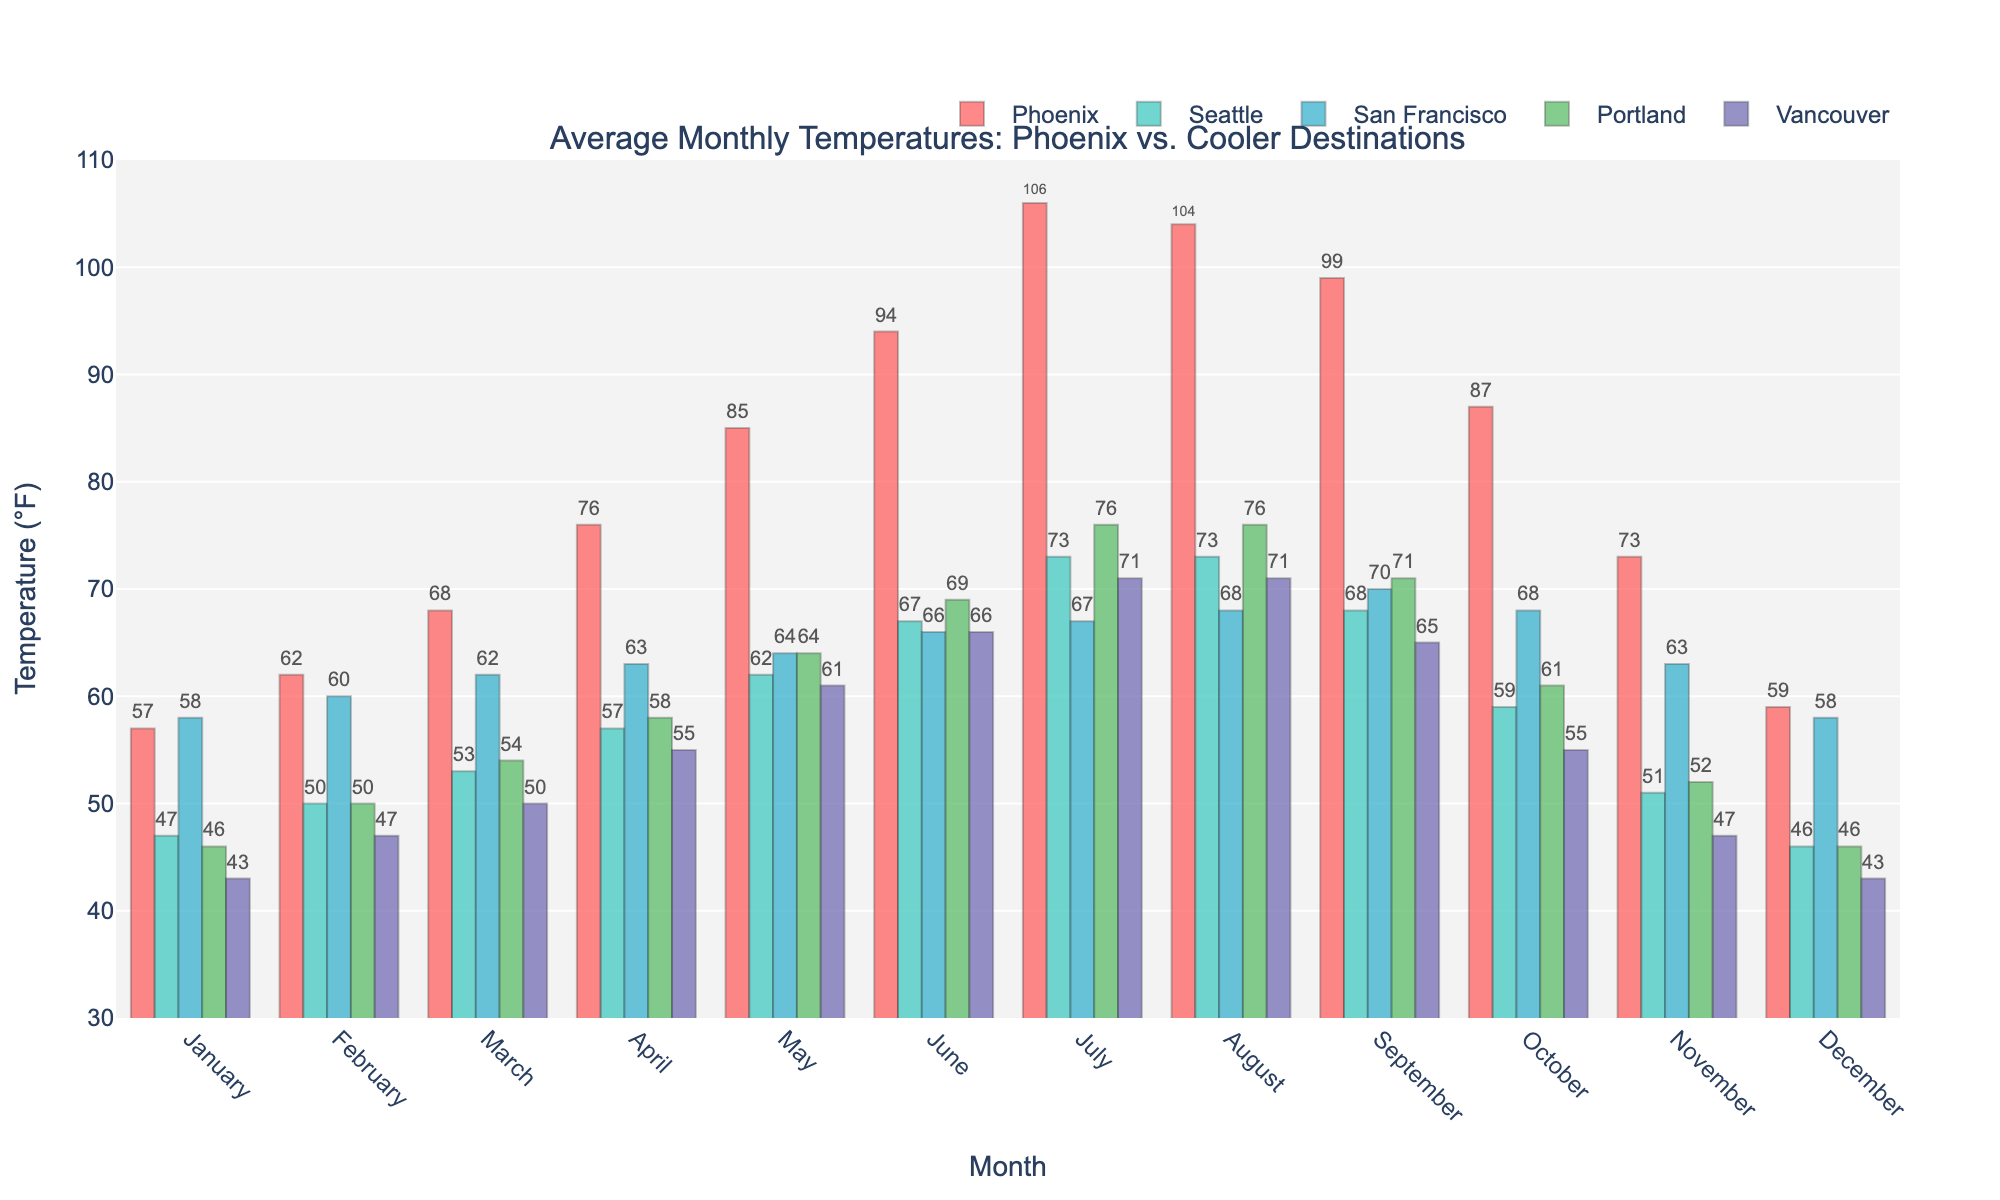Which month has the highest average temperature in Phoenix? To determine the highest average temperature in Phoenix, look for the tallest bar representing Phoenix. The tallest bar is in July, reaching 106°F.
Answer: July Which city stays coolest in July? To find the coolest city in July, compare the heights of the bars representing each city. Vancouver and San Francisco both share the shortest bar at 67°F.
Answer: San Francisco and Vancouver What is the average temperature difference between Phoenix and Seattle in March? Take the temperature for Phoenix in March (68°F) and subtract the temperature in Seattle (53°F). The difference is 68 - 53 = 15°F.
Answer: 15°F During which month does San Francisco have the same average temperature as Phoenix? Compare the temperatures of San Francisco and Phoenix for each month. In January, San Francisco and Phoenix both have average temperatures of 58°F.
Answer: January What is the temperature range in Phoenix throughout the year? Identify the highest and lowest temperatures in Phoenix's bar series. The highest is 106°F (July), and the lowest is 57°F (January). The range is 106 - 57 = 49°F.
Answer: 49°F Which month shows the greatest temperature difference between Phoenix and Vancouver? Calculate the temperature difference between Phoenix and Vancouver for each month and identify the greatest difference. July has the largest difference: Phoenix 106°F - Vancouver 71°F = 35°F.
Answer: July In which months is Phoenix's average temperature higher than all other cities? Check the temperatures for each city against Phoenix's temperature. Phoenix's temperatures are higher than all others in June, July, August, and September.
Answer: June, July, August, September How does the average temperature in Phoenix in December compare to that in Portland? Compare the bars for Phoenix and Portland in December. Phoenix has an average temperature of 59°F, while Portland has 46°F. So, Phoenix is warmer.
Answer: Phoenix is warmer If you prefer cities where the summer temperature does not exceed 70°F, which cities from the list meet this criterion? Identify the cities that have a maximum summer (July) temperature at or below 70°F. San Francisco (67°F) and Vancouver (71°F) do not exceed 70°F.
Answer: San Francisco and Vancouver What's the average difference in temperature between Phoenix and Vancouver across all months? Calculate the monthly differences between Phoenix and Vancouver, then find the average of these differences:
((57-43) + (62-47) + (68-50) + (76-55) + (85-61) + (94-66) + (106-71) + (104-71) + (99-65) + (87-55) + (73-47) + (59-43)) / 12 = (198 / 12) = 16.5°F.
Answer: 16.5°F 